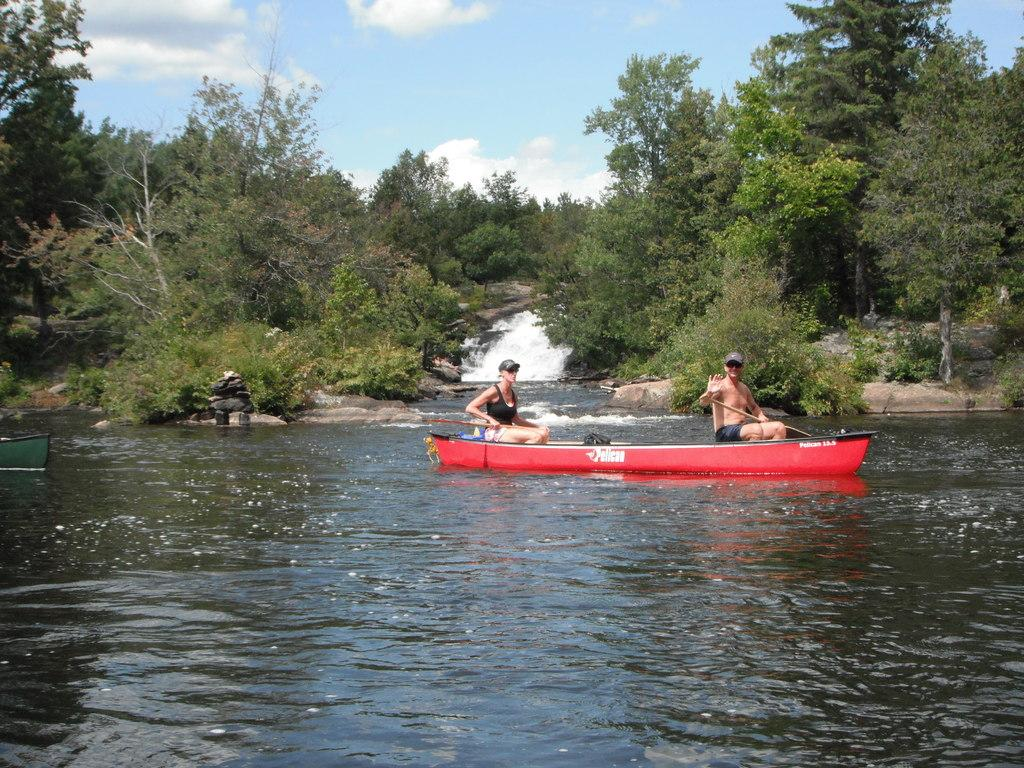What is the main subject of the image? The main subject of the image is water. What is on the water in the image? There are boats on the water in the image. What are the people in the boats doing? People are sitting in the boats. What can be seen in the background of the image? There are trees and the sky visible in the background of the image. What type of office can be seen in the image? There is no office present in the image; it features water, boats, people, trees, and the sky. How does the water twist in the image? The water does not twist in the image; it appears to be calm and still. 